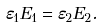<formula> <loc_0><loc_0><loc_500><loc_500>\varepsilon _ { 1 } E _ { 1 } = \varepsilon _ { 2 } E _ { 2 } .</formula> 